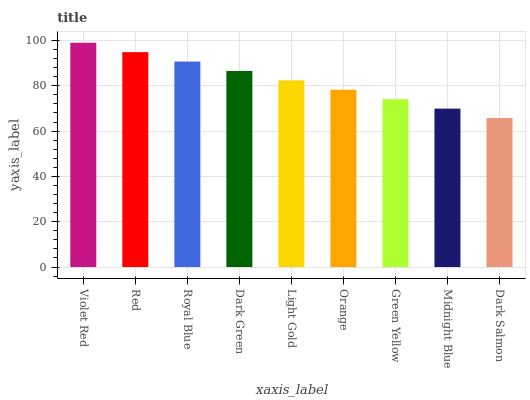Is Dark Salmon the minimum?
Answer yes or no. Yes. Is Violet Red the maximum?
Answer yes or no. Yes. Is Red the minimum?
Answer yes or no. No. Is Red the maximum?
Answer yes or no. No. Is Violet Red greater than Red?
Answer yes or no. Yes. Is Red less than Violet Red?
Answer yes or no. Yes. Is Red greater than Violet Red?
Answer yes or no. No. Is Violet Red less than Red?
Answer yes or no. No. Is Light Gold the high median?
Answer yes or no. Yes. Is Light Gold the low median?
Answer yes or no. Yes. Is Red the high median?
Answer yes or no. No. Is Dark Salmon the low median?
Answer yes or no. No. 